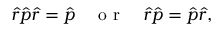Convert formula to latex. <formula><loc_0><loc_0><loc_500><loc_500>\hat { r } \hat { p } \hat { r } = \hat { p } \quad o r \quad \hat { r } \hat { p } = \hat { p } \hat { r } ,</formula> 